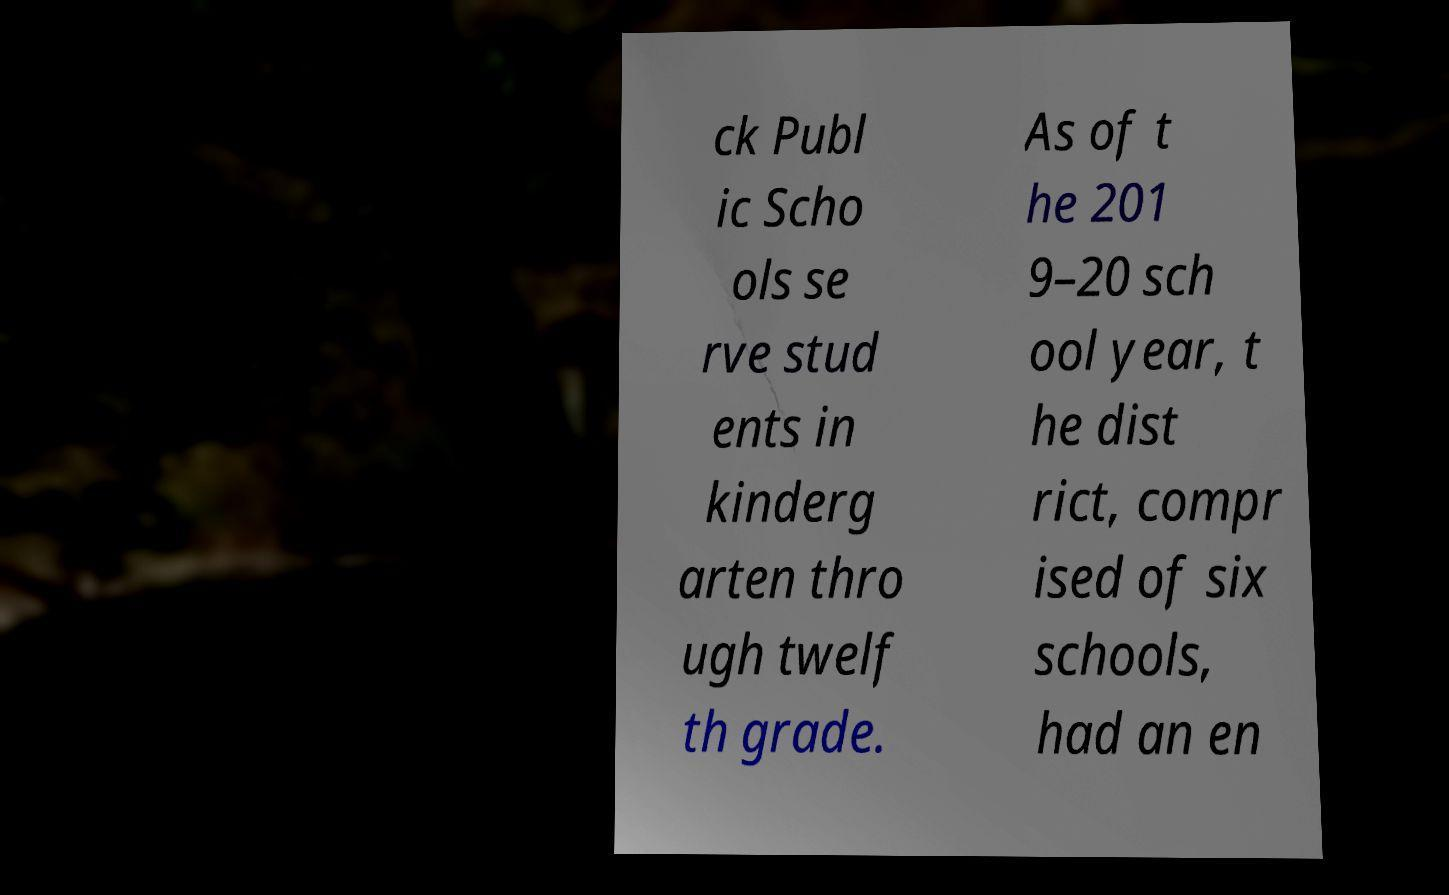Could you assist in decoding the text presented in this image and type it out clearly? ck Publ ic Scho ols se rve stud ents in kinderg arten thro ugh twelf th grade. As of t he 201 9–20 sch ool year, t he dist rict, compr ised of six schools, had an en 